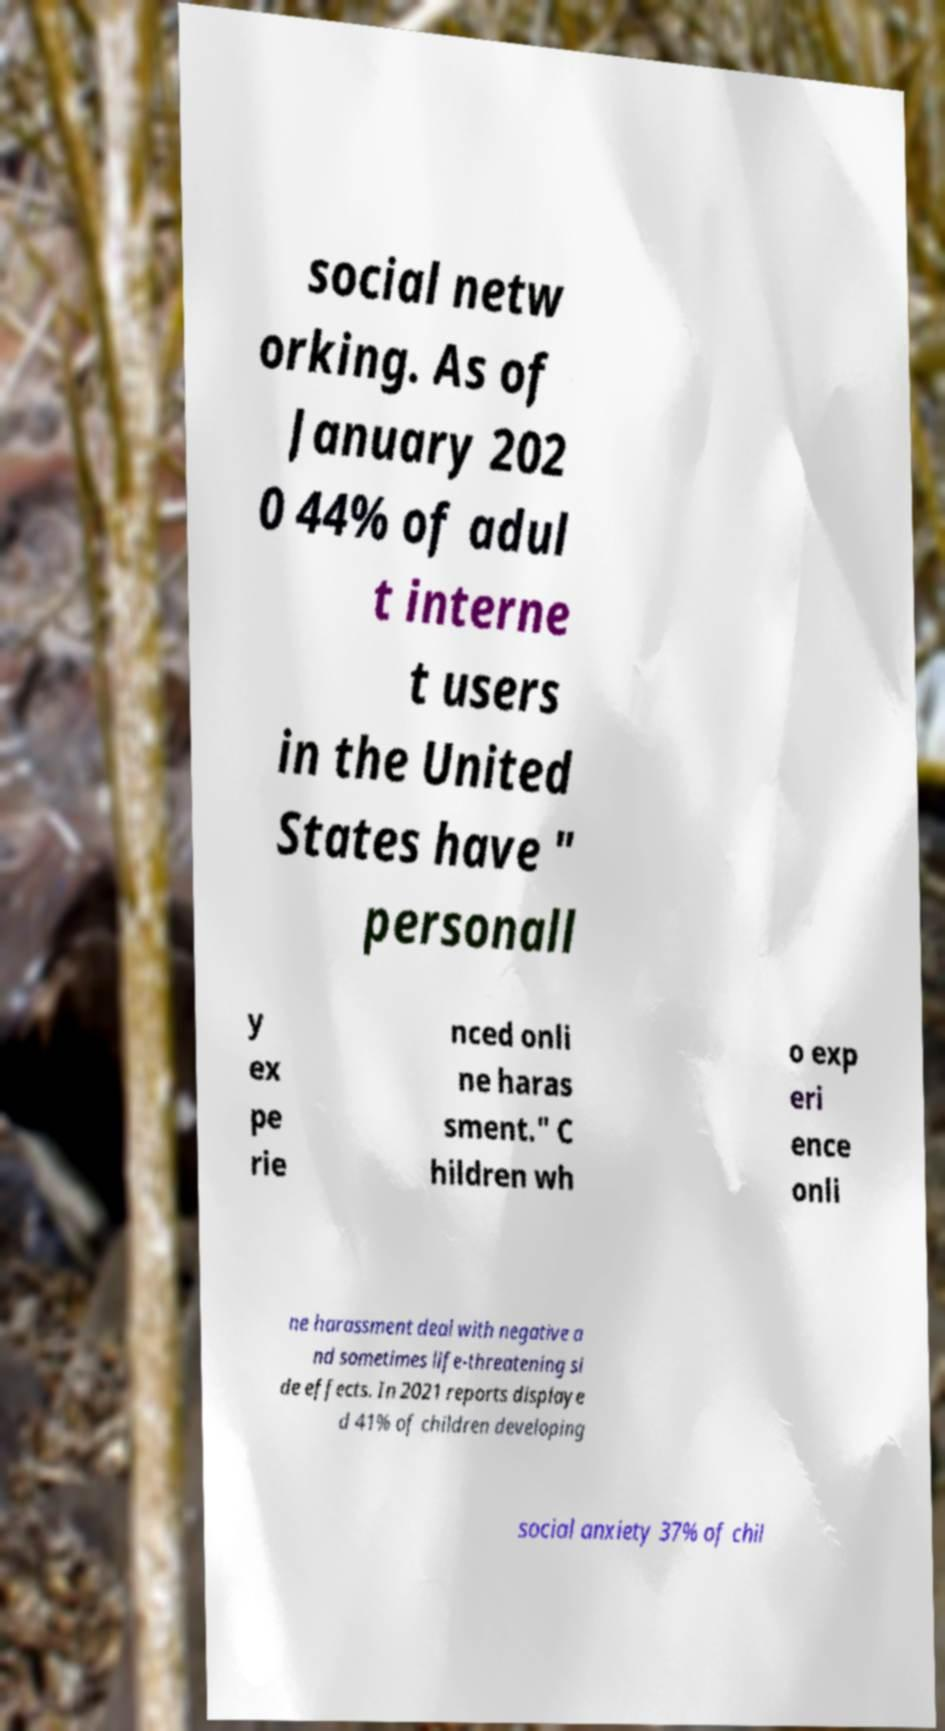Could you extract and type out the text from this image? social netw orking. As of January 202 0 44% of adul t interne t users in the United States have " personall y ex pe rie nced onli ne haras sment." C hildren wh o exp eri ence onli ne harassment deal with negative a nd sometimes life-threatening si de effects. In 2021 reports displaye d 41% of children developing social anxiety 37% of chil 